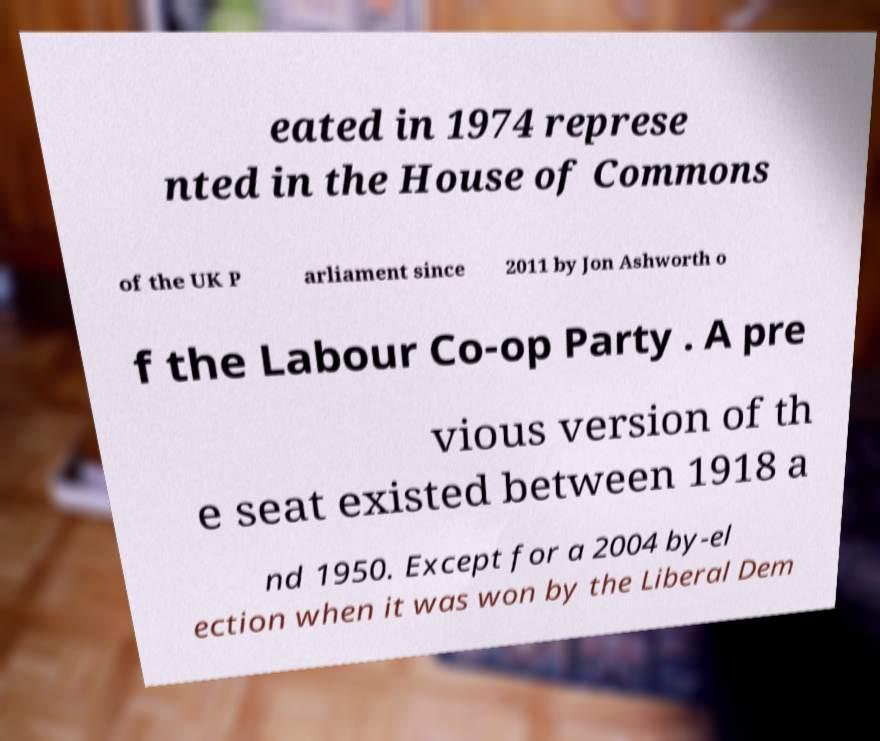Could you assist in decoding the text presented in this image and type it out clearly? eated in 1974 represe nted in the House of Commons of the UK P arliament since 2011 by Jon Ashworth o f the Labour Co-op Party . A pre vious version of th e seat existed between 1918 a nd 1950. Except for a 2004 by-el ection when it was won by the Liberal Dem 